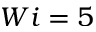<formula> <loc_0><loc_0><loc_500><loc_500>W i = 5</formula> 